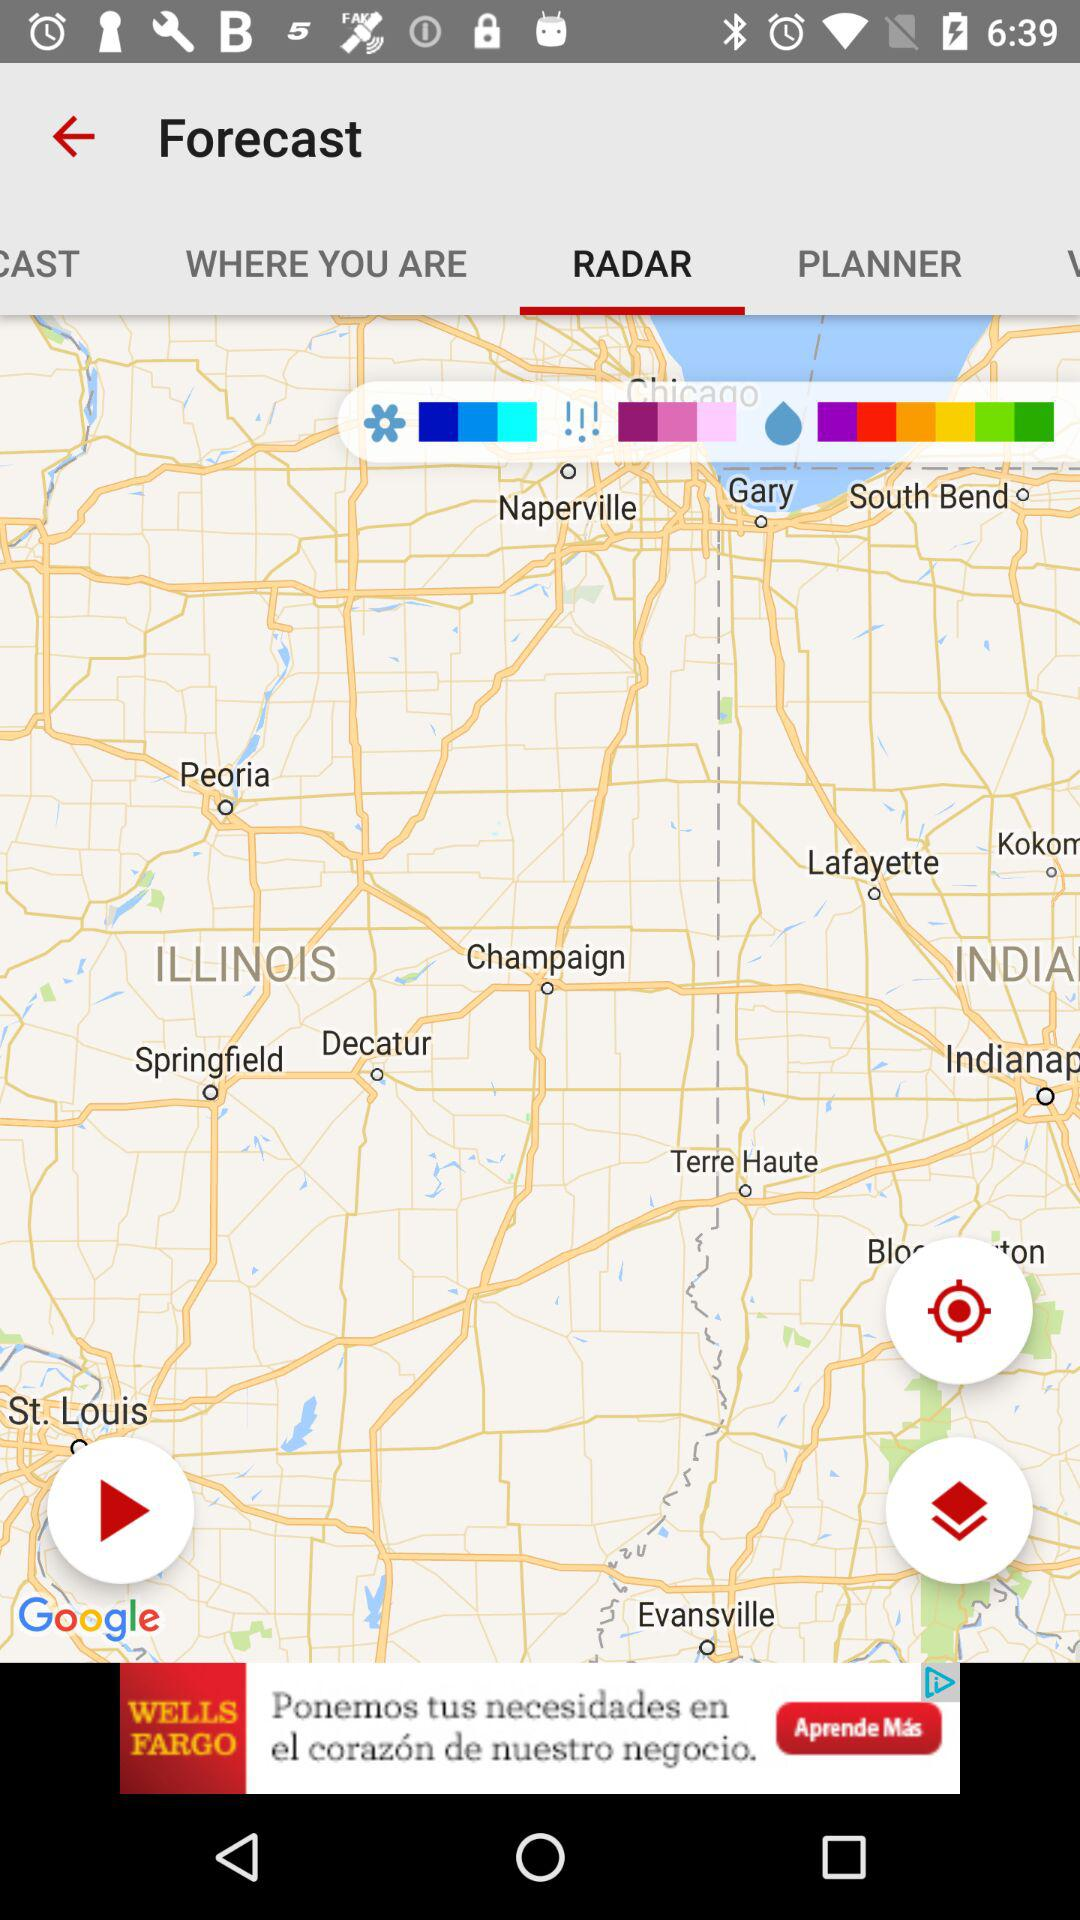What is the app name? The app name is "Forecast". 